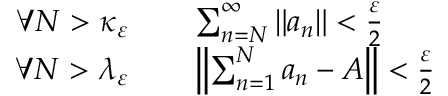Convert formula to latex. <formula><loc_0><loc_0><loc_500><loc_500>\begin{array} { r l } { \forall N > \kappa _ { \varepsilon } } & \quad \sum _ { n = N } ^ { \infty } \| a _ { n } \| < { \frac { \varepsilon } { 2 } } } \\ { \forall N > \lambda _ { \varepsilon } } & \quad \left \| \sum _ { n = 1 } ^ { N } a _ { n } - A \right \| < { \frac { \varepsilon } { 2 } } } \end{array}</formula> 